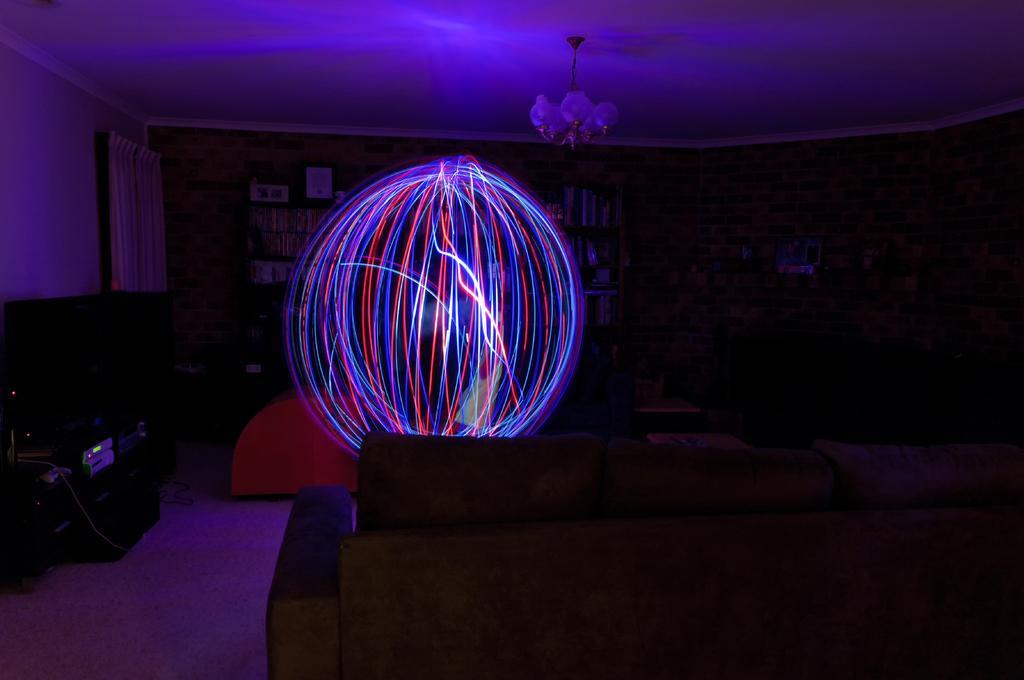Can you describe this image briefly? In this image I can see a couch, a lamp, the ceiling, the wall, a book shelf with number of books in it and the curtain. In the center of the room I can see a circle shaped light which is red, blue and white in color. 